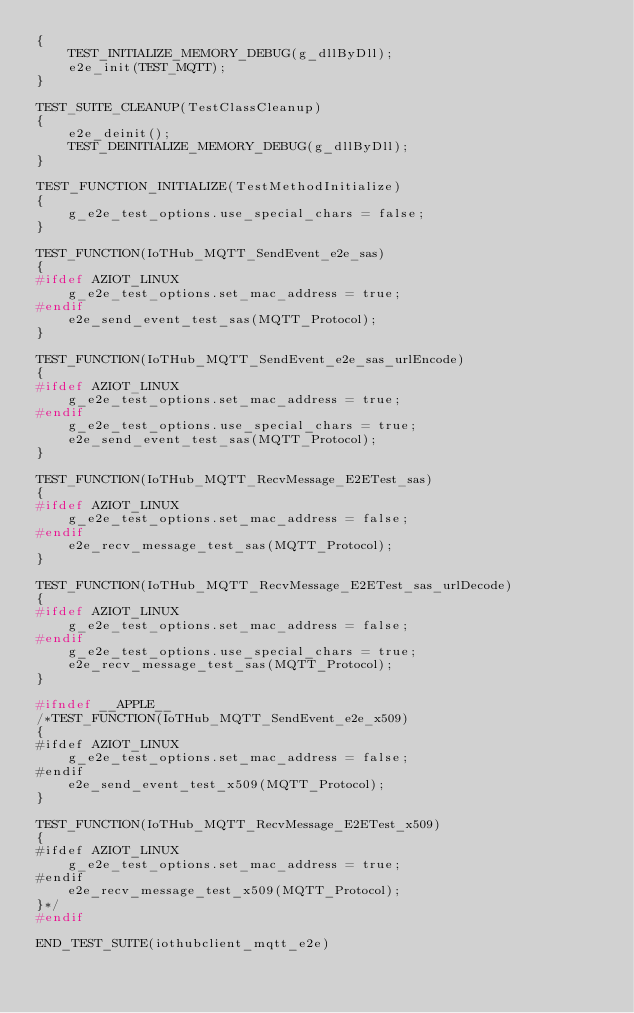Convert code to text. <code><loc_0><loc_0><loc_500><loc_500><_C_>{
    TEST_INITIALIZE_MEMORY_DEBUG(g_dllByDll);
    e2e_init(TEST_MQTT);
}

TEST_SUITE_CLEANUP(TestClassCleanup)
{
    e2e_deinit();
    TEST_DEINITIALIZE_MEMORY_DEBUG(g_dllByDll);
}

TEST_FUNCTION_INITIALIZE(TestMethodInitialize)
{
    g_e2e_test_options.use_special_chars = false;
}

TEST_FUNCTION(IoTHub_MQTT_SendEvent_e2e_sas)
{
#ifdef AZIOT_LINUX
    g_e2e_test_options.set_mac_address = true;
#endif
    e2e_send_event_test_sas(MQTT_Protocol);
}

TEST_FUNCTION(IoTHub_MQTT_SendEvent_e2e_sas_urlEncode)
{
#ifdef AZIOT_LINUX
    g_e2e_test_options.set_mac_address = true;
#endif
    g_e2e_test_options.use_special_chars = true;
    e2e_send_event_test_sas(MQTT_Protocol);
}

TEST_FUNCTION(IoTHub_MQTT_RecvMessage_E2ETest_sas)
{
#ifdef AZIOT_LINUX
    g_e2e_test_options.set_mac_address = false;
#endif
    e2e_recv_message_test_sas(MQTT_Protocol);
}

TEST_FUNCTION(IoTHub_MQTT_RecvMessage_E2ETest_sas_urlDecode)
{
#ifdef AZIOT_LINUX
    g_e2e_test_options.set_mac_address = false;
#endif
    g_e2e_test_options.use_special_chars = true;
    e2e_recv_message_test_sas(MQTT_Protocol);
}

#ifndef __APPLE__
/*TEST_FUNCTION(IoTHub_MQTT_SendEvent_e2e_x509)
{
#ifdef AZIOT_LINUX
    g_e2e_test_options.set_mac_address = false;
#endif
    e2e_send_event_test_x509(MQTT_Protocol);
}

TEST_FUNCTION(IoTHub_MQTT_RecvMessage_E2ETest_x509)
{
#ifdef AZIOT_LINUX
    g_e2e_test_options.set_mac_address = true;
#endif
    e2e_recv_message_test_x509(MQTT_Protocol);
}*/
#endif

END_TEST_SUITE(iothubclient_mqtt_e2e)
</code> 